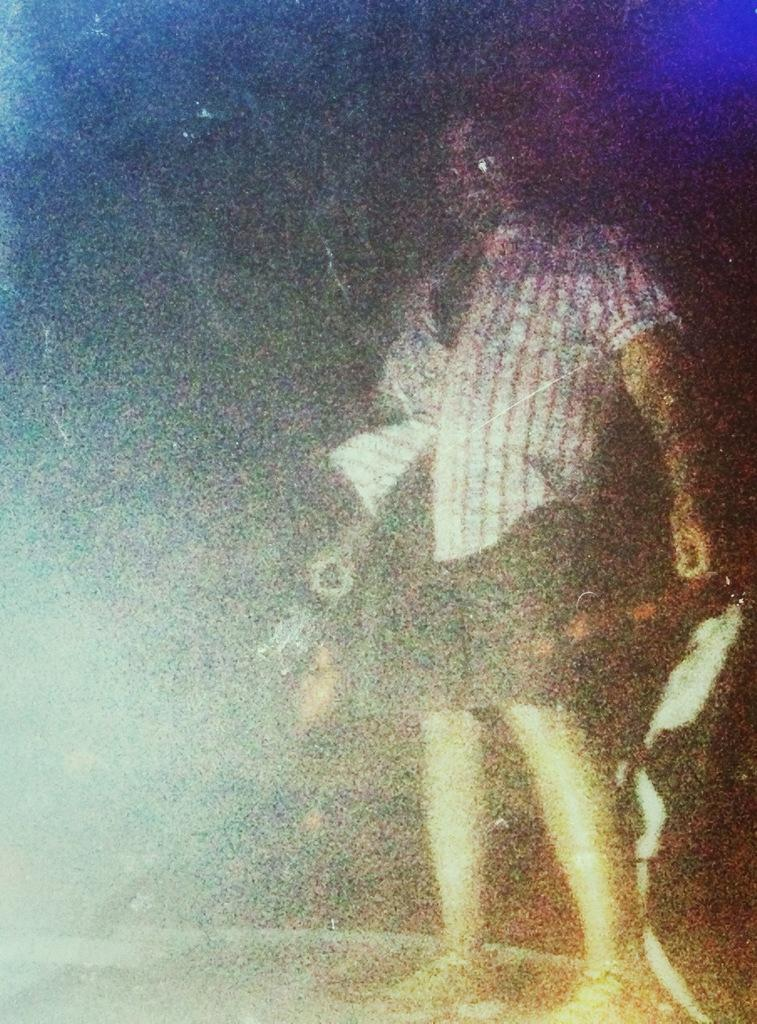What is the main subject in the image? There is a person standing in the image. What team does the person belong to in the image? There is no information about a team or any affiliation in the image. 